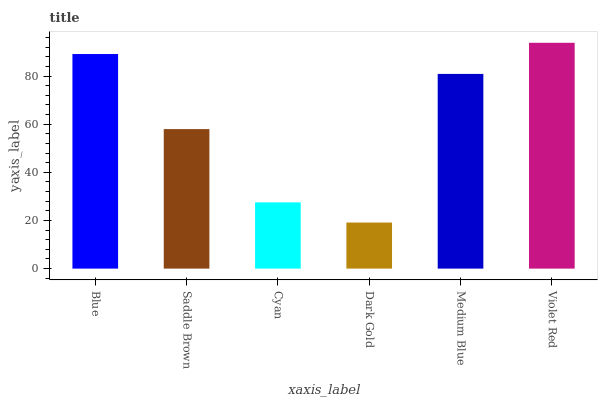Is Dark Gold the minimum?
Answer yes or no. Yes. Is Violet Red the maximum?
Answer yes or no. Yes. Is Saddle Brown the minimum?
Answer yes or no. No. Is Saddle Brown the maximum?
Answer yes or no. No. Is Blue greater than Saddle Brown?
Answer yes or no. Yes. Is Saddle Brown less than Blue?
Answer yes or no. Yes. Is Saddle Brown greater than Blue?
Answer yes or no. No. Is Blue less than Saddle Brown?
Answer yes or no. No. Is Medium Blue the high median?
Answer yes or no. Yes. Is Saddle Brown the low median?
Answer yes or no. Yes. Is Blue the high median?
Answer yes or no. No. Is Violet Red the low median?
Answer yes or no. No. 